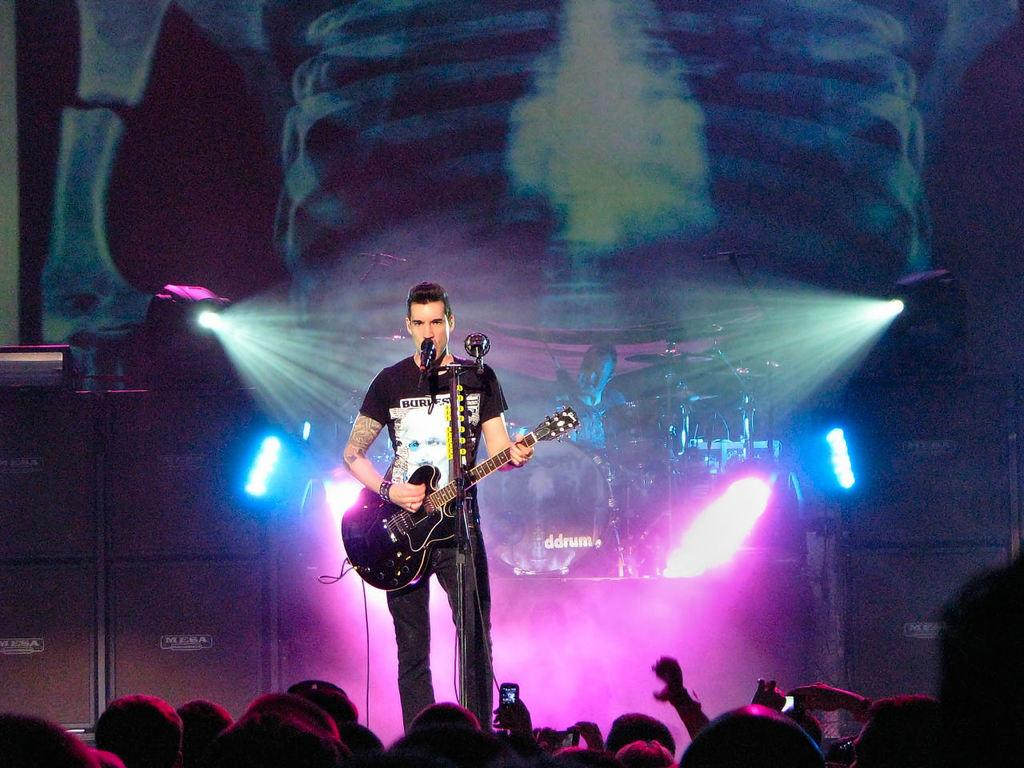What is the man in the image doing? The man is playing a guitar in the image. What is the man positioned near in the image? The man is in front of a microphone. What are other people doing in the image? Other people are playing musical instruments in the image. What objects are some people holding in the image? Some people are holding a mobile in the image. What type of flower is being used as a prop in the image? There is no flower present in the image; it features people playing musical instruments and holding a mobile. 